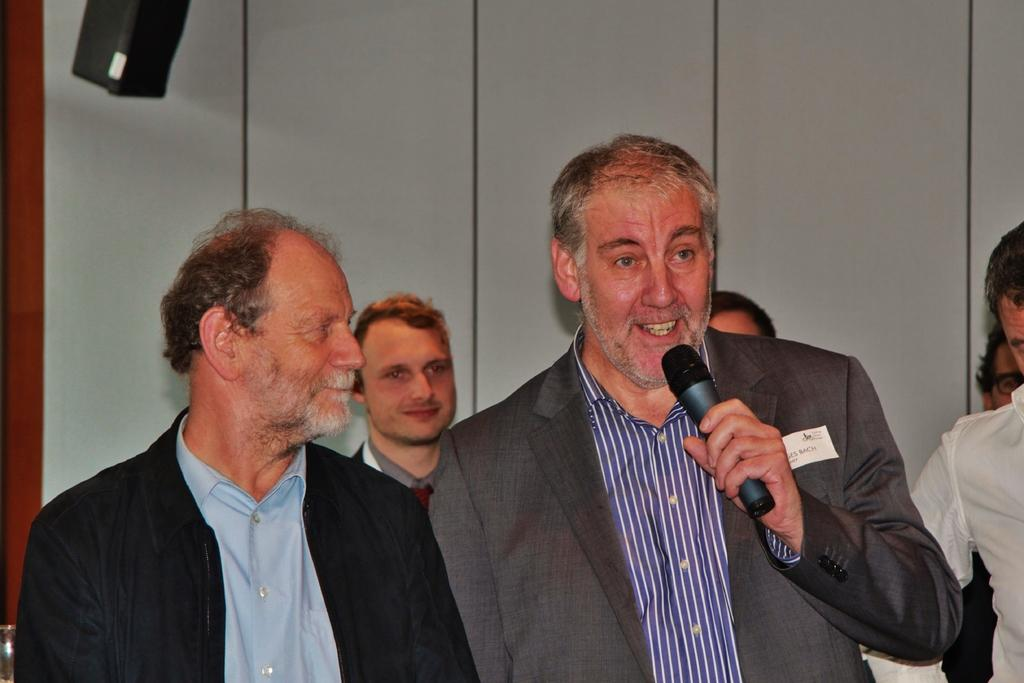How many people are in the image? There is a group of people standing in the image. What is one person holding in their hand? One person is holding a microphone in their hand. What can be seen in the background of the image? There is a wall visible in the background of the image. What type of crayon is being used to draw on the wall in the image? There is no crayon or drawing on the wall in the image; it only shows a group of people and a wall in the background. 